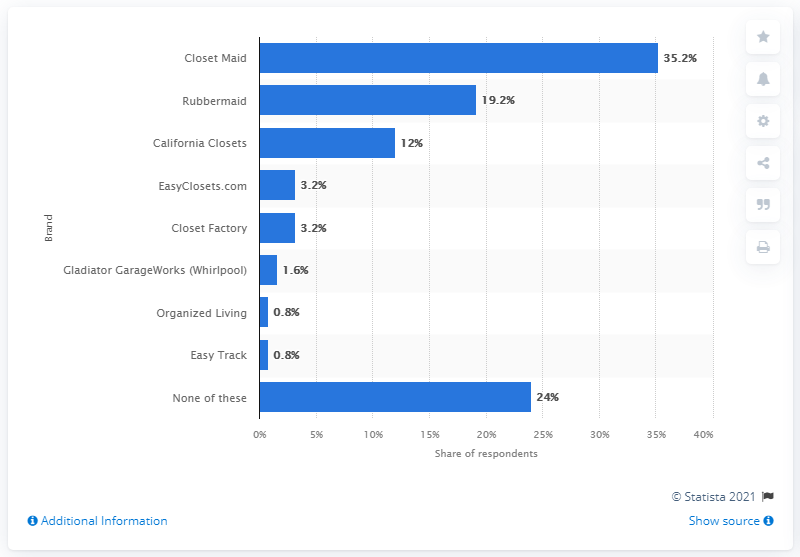Specify some key components in this picture. According to the survey results, 35.2% of respondents reported using Closet Maid as the brand of closet and organization systems they used the most. 